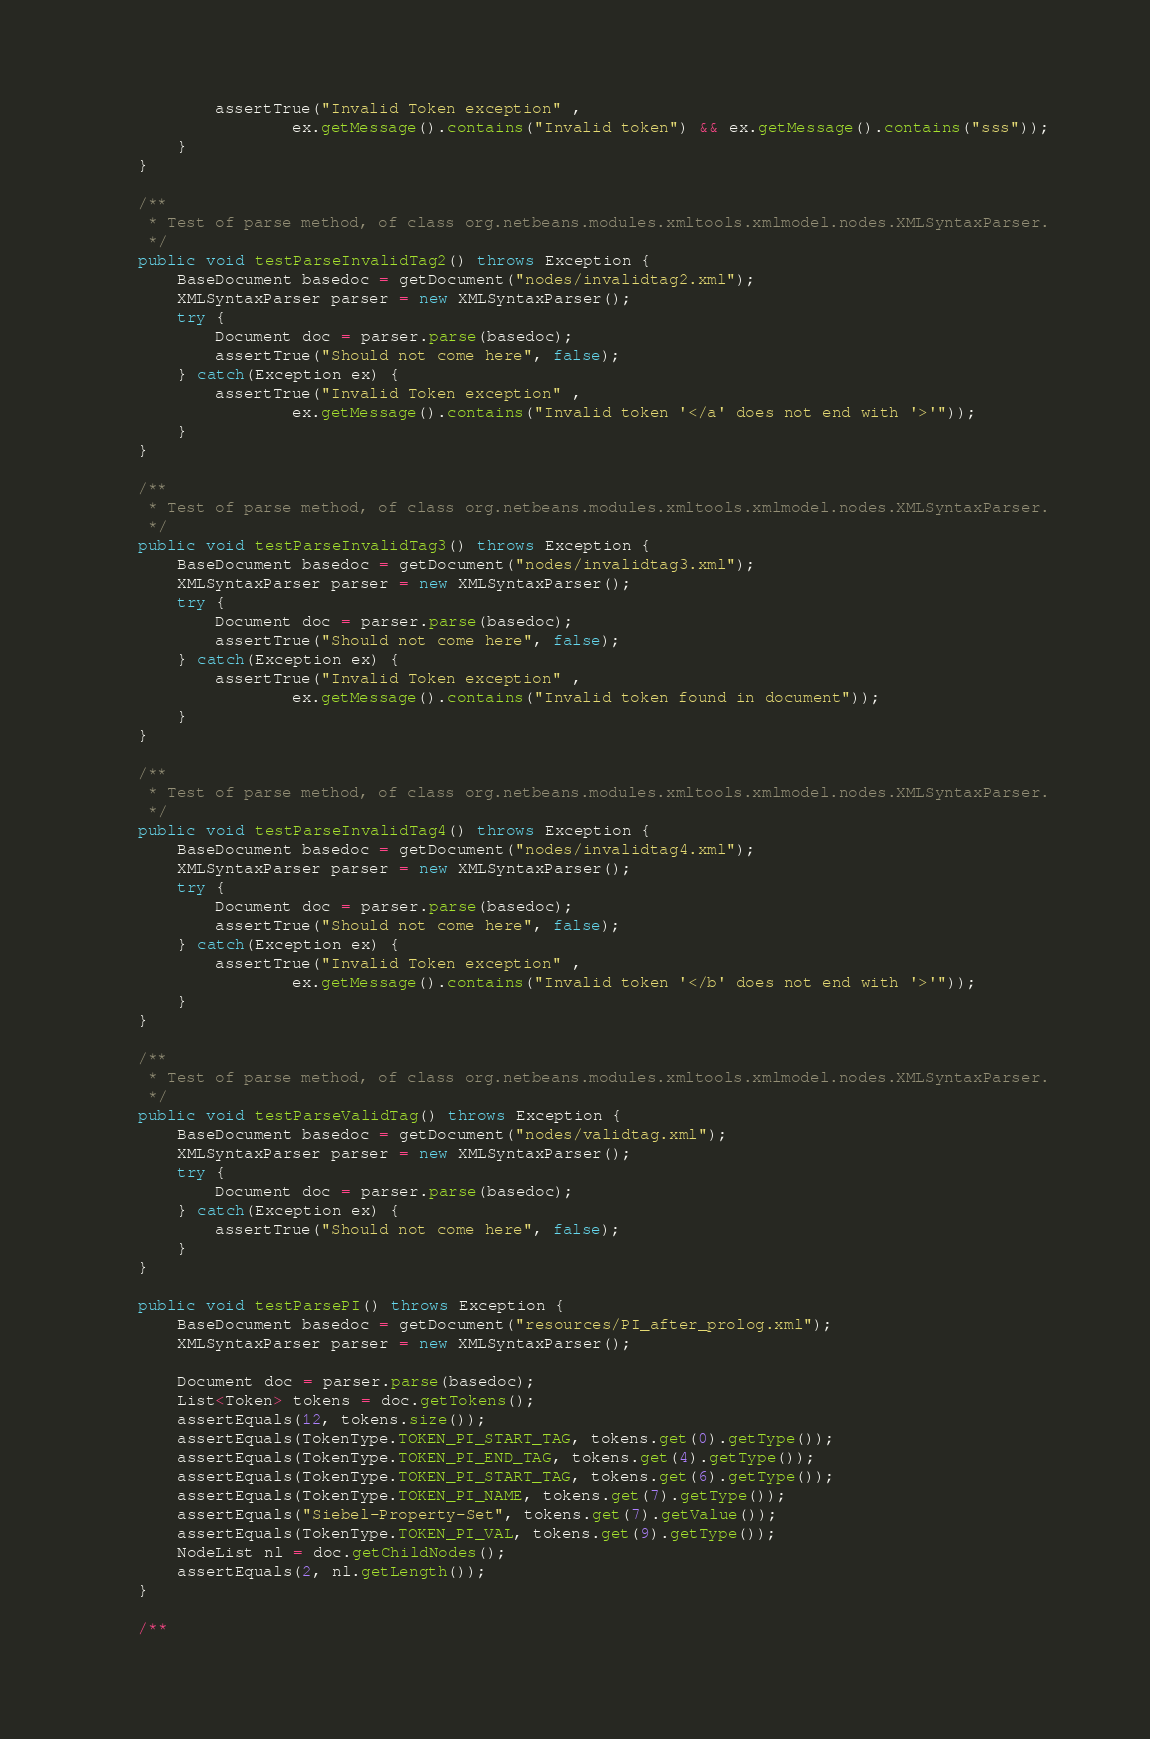Convert code to text. <code><loc_0><loc_0><loc_500><loc_500><_Java_>            assertTrue("Invalid Token exception" ,
                    ex.getMessage().contains("Invalid token") && ex.getMessage().contains("sss"));
        }
    }
    
    /**
     * Test of parse method, of class org.netbeans.modules.xmltools.xmlmodel.nodes.XMLSyntaxParser.
     */
    public void testParseInvalidTag2() throws Exception {
        BaseDocument basedoc = getDocument("nodes/invalidtag2.xml");
        XMLSyntaxParser parser = new XMLSyntaxParser();
        try {
            Document doc = parser.parse(basedoc);
            assertTrue("Should not come here", false);
        } catch(Exception ex) {
            assertTrue("Invalid Token exception" ,
                    ex.getMessage().contains("Invalid token '</a' does not end with '>'"));
        }
    }   
    
    /**
     * Test of parse method, of class org.netbeans.modules.xmltools.xmlmodel.nodes.XMLSyntaxParser.
     */
    public void testParseInvalidTag3() throws Exception {
        BaseDocument basedoc = getDocument("nodes/invalidtag3.xml");
        XMLSyntaxParser parser = new XMLSyntaxParser();
        try {
            Document doc = parser.parse(basedoc);
            assertTrue("Should not come here", false);
        } catch(Exception ex) {
            assertTrue("Invalid Token exception" ,
                    ex.getMessage().contains("Invalid token found in document"));
        }
    }
    
    /**
     * Test of parse method, of class org.netbeans.modules.xmltools.xmlmodel.nodes.XMLSyntaxParser.
     */
    public void testParseInvalidTag4() throws Exception {
        BaseDocument basedoc = getDocument("nodes/invalidtag4.xml");
        XMLSyntaxParser parser = new XMLSyntaxParser();
        try {
            Document doc = parser.parse(basedoc);
            assertTrue("Should not come here", false);
        } catch(Exception ex) {
            assertTrue("Invalid Token exception" ,
                    ex.getMessage().contains("Invalid token '</b' does not end with '>'"));
        }
    }    
    
    /**
     * Test of parse method, of class org.netbeans.modules.xmltools.xmlmodel.nodes.XMLSyntaxParser.
     */
    public void testParseValidTag() throws Exception {
        BaseDocument basedoc = getDocument("nodes/validtag.xml");
        XMLSyntaxParser parser = new XMLSyntaxParser();
        try {
            Document doc = parser.parse(basedoc);            
        } catch(Exception ex) {
            assertTrue("Should not come here", false);
        }
    }    

    public void testParsePI() throws Exception {
        BaseDocument basedoc = getDocument("resources/PI_after_prolog.xml");
        XMLSyntaxParser parser = new XMLSyntaxParser();

        Document doc = parser.parse(basedoc);            
        List<Token> tokens = doc.getTokens();
        assertEquals(12, tokens.size());
        assertEquals(TokenType.TOKEN_PI_START_TAG, tokens.get(0).getType());
        assertEquals(TokenType.TOKEN_PI_END_TAG, tokens.get(4).getType());
        assertEquals(TokenType.TOKEN_PI_START_TAG, tokens.get(6).getType());
        assertEquals(TokenType.TOKEN_PI_NAME, tokens.get(7).getType());
        assertEquals("Siebel-Property-Set", tokens.get(7).getValue());
        assertEquals(TokenType.TOKEN_PI_VAL, tokens.get(9).getType());
        NodeList nl = doc.getChildNodes();
        assertEquals(2, nl.getLength());    
    }    

    /**</code> 